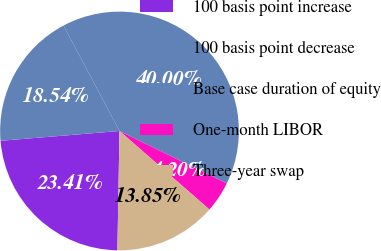<chart> <loc_0><loc_0><loc_500><loc_500><pie_chart><fcel>100 basis point increase<fcel>100 basis point decrease<fcel>Base case duration of equity<fcel>One-month LIBOR<fcel>Three-year swap<nl><fcel>23.41%<fcel>18.54%<fcel>40.0%<fcel>4.2%<fcel>13.85%<nl></chart> 